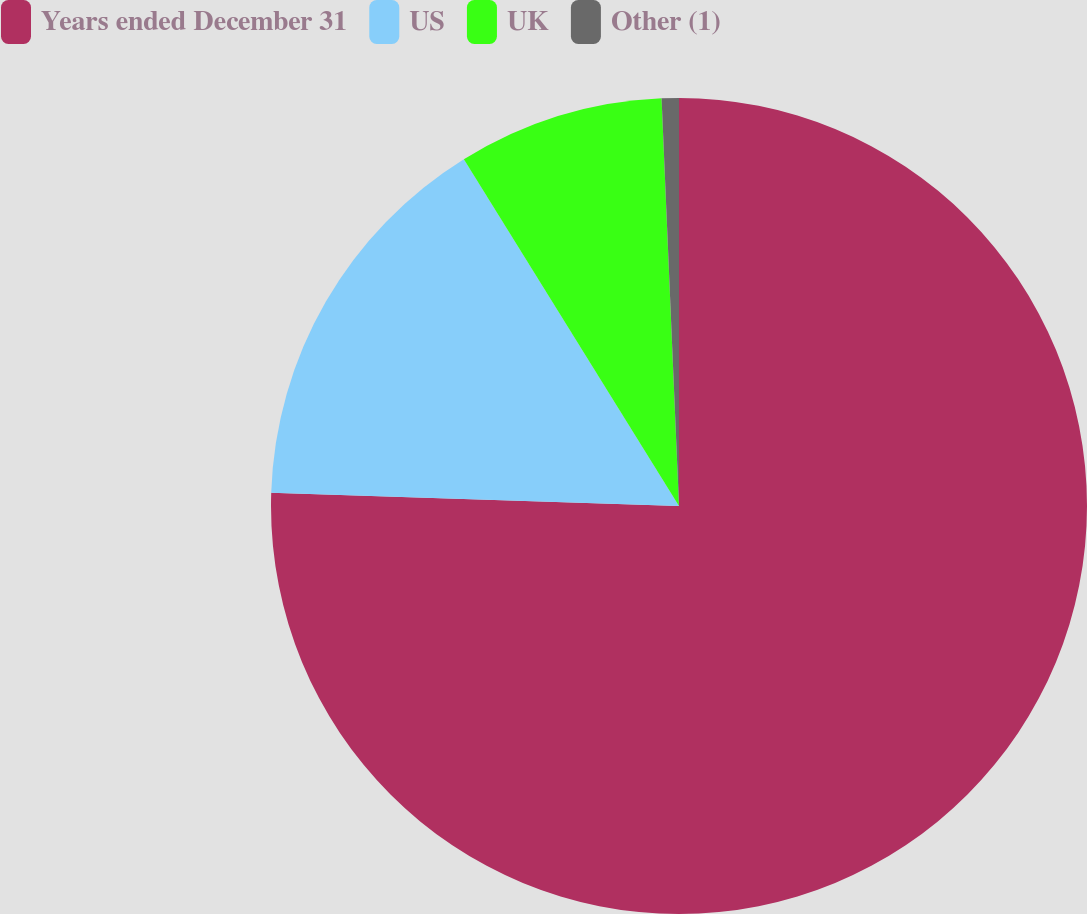<chart> <loc_0><loc_0><loc_500><loc_500><pie_chart><fcel>Years ended December 31<fcel>US<fcel>UK<fcel>Other (1)<nl><fcel>75.52%<fcel>15.64%<fcel>8.16%<fcel>0.68%<nl></chart> 